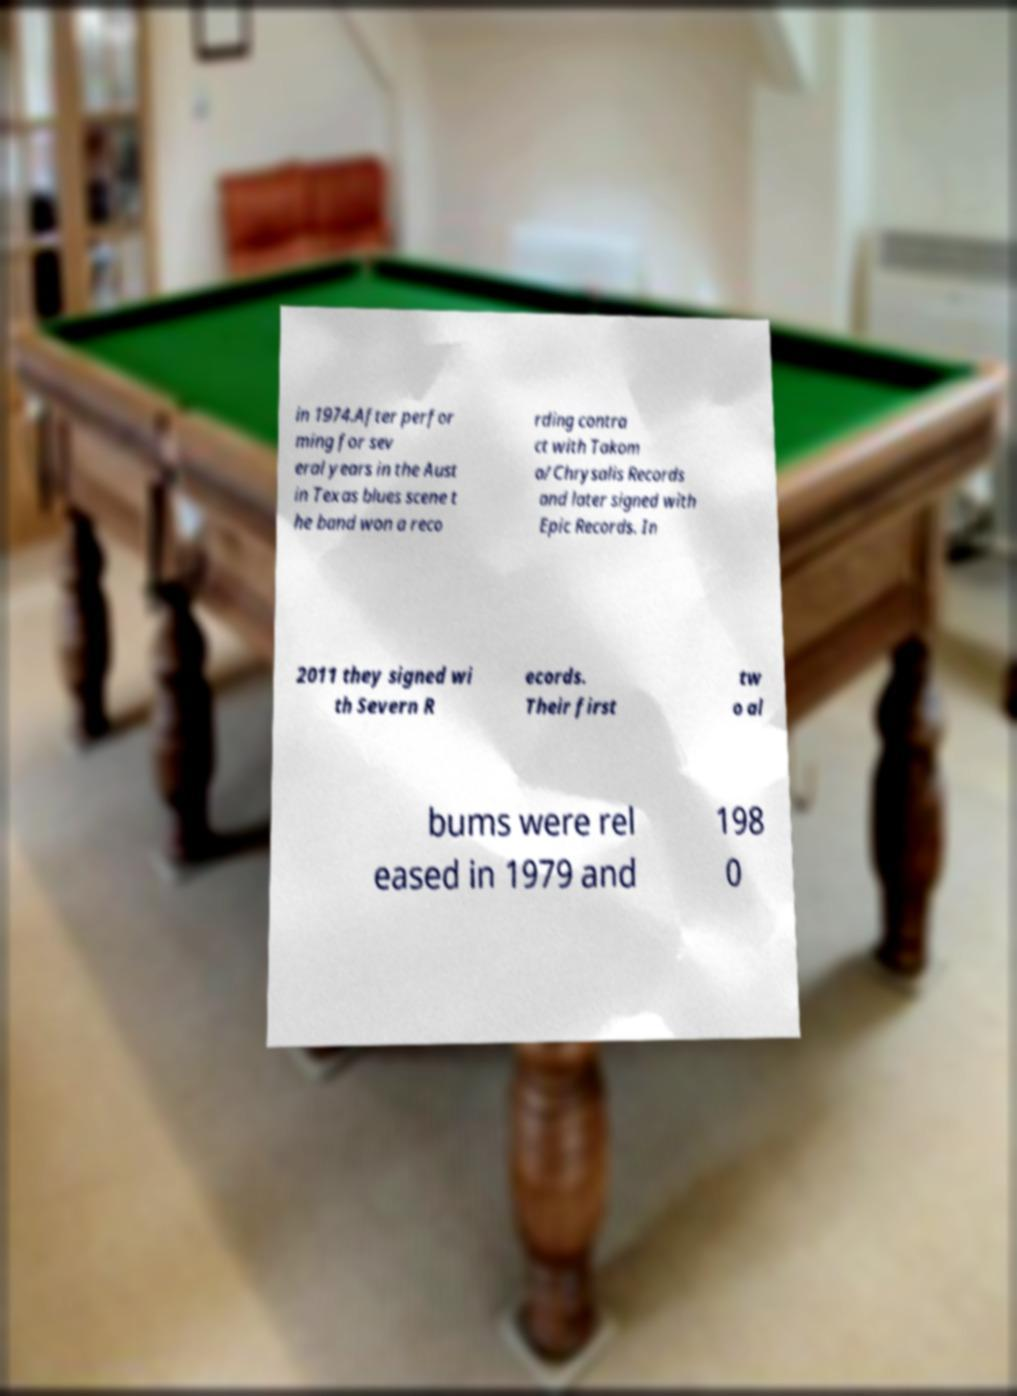Can you accurately transcribe the text from the provided image for me? in 1974.After perfor ming for sev eral years in the Aust in Texas blues scene t he band won a reco rding contra ct with Takom a/Chrysalis Records and later signed with Epic Records. In 2011 they signed wi th Severn R ecords. Their first tw o al bums were rel eased in 1979 and 198 0 